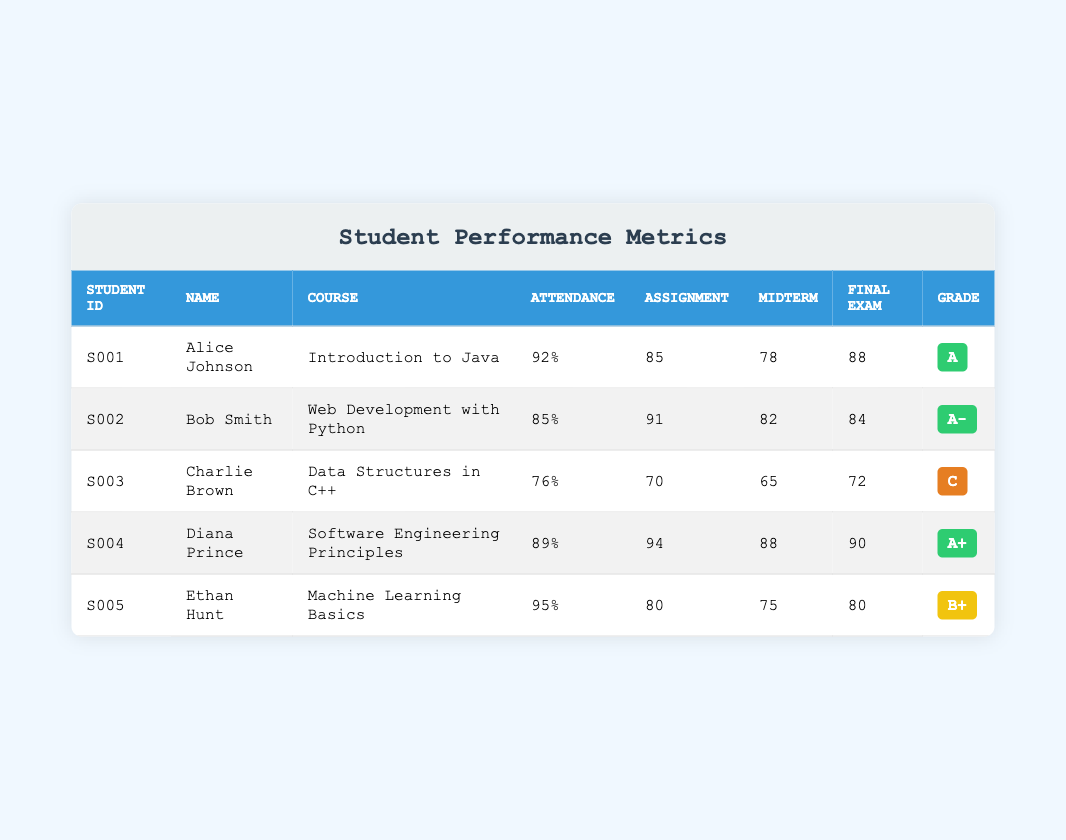What is the overall grade of Bob Smith? Bob Smith is listed in the table, and his overall grade is found in the "Grade" column, where it states A-.
Answer: A- Which student has the highest attendance percentage? By examining the "Attendance" column, we see that Ethan Hunt has the highest attendance percentage at 95%.
Answer: 95% What is the average final exam score for all students? The final exam scores for all students are 88, 84, 72, 90, and 80. The sum of these scores is (88 + 84 + 72 + 90 + 80) = 414. Dividing this by the number of students (5), we get an average of 414 / 5 = 82.8.
Answer: 82.8 Did any student get a final exam score below 75? Looking through the final exam scores, Charlie Brown scored 72, which is below 75. Therefore, the answer is yes.
Answer: Yes How many students received an overall grade of A or higher? To find this, we check the "Grade" column for A and A+ grades. Alice Johnson, Diana Prince, and Bob Smith all have A or higher grades, totaling three students.
Answer: 3 Who scored the lowest on assignments, and what was their score? The assignment scores in the table are 85, 91, 70, 94, and 80. The lowest score is 70, achieved by Charlie Brown.
Answer: Charlie Brown, 70 What is the difference between the attendance percentage of Alice Johnson and Ethan Hunt? Alice Johnson has an attendance of 92%, while Ethan Hunt’s attendance is 95%. To find the difference, we subtract: 95 - 92 = 3.
Answer: 3 Which course had the student with the lowest midterm score, and what was that score? The midterm scores listed are 78, 82, 65, 88, and 75. Charlie Brown has the lowest midterm score of 65, and he is enrolled in "Data Structures in C++".
Answer: Data Structures in C++, 65 How many students had a final exam score of 80 or higher? The final exam scores of each student are examined: 88, 84, 72, 90, and 80. Only Charlie Brown scored below 80; the rest scored 80 or above. Thus, the number of students with scores of 80 or higher is four.
Answer: 4 